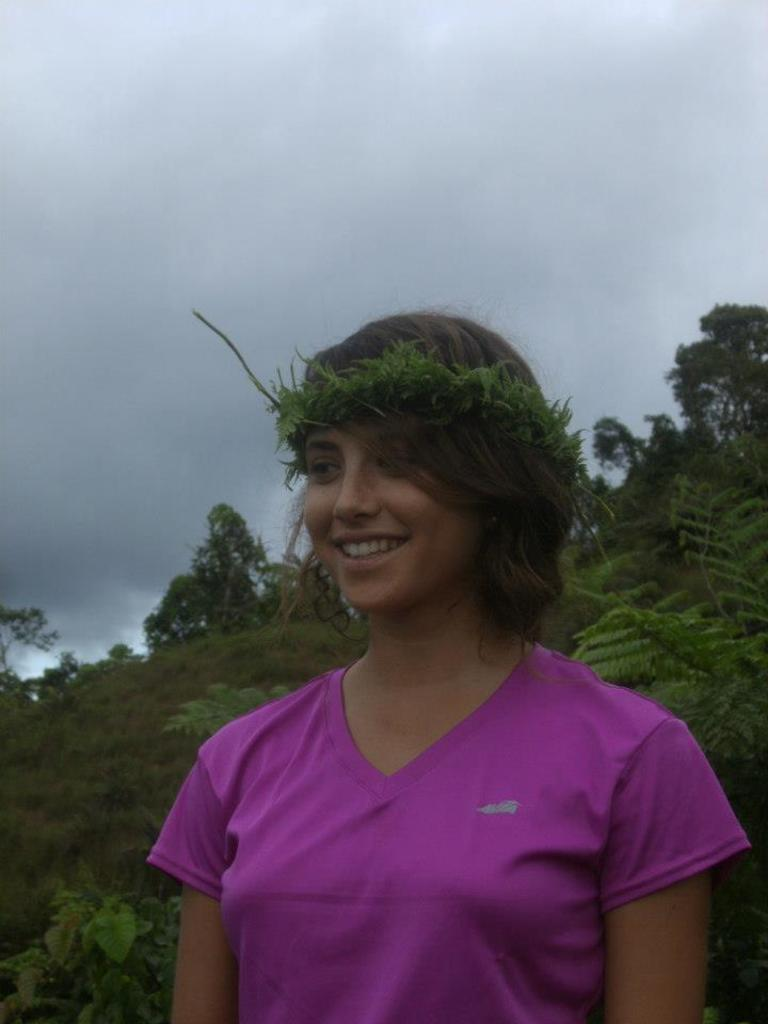Who is the main subject in the image? There is a woman in the center of the image. What can be seen in the background of the image? There are trees and the sky visible in the background of the image. Are there any clouds in the background? Yes, clouds are present in the background of the image. What type of pear is the woman holding in the image? There is no pear present in the image; the woman is not holding any object. 